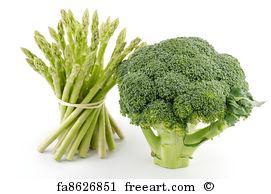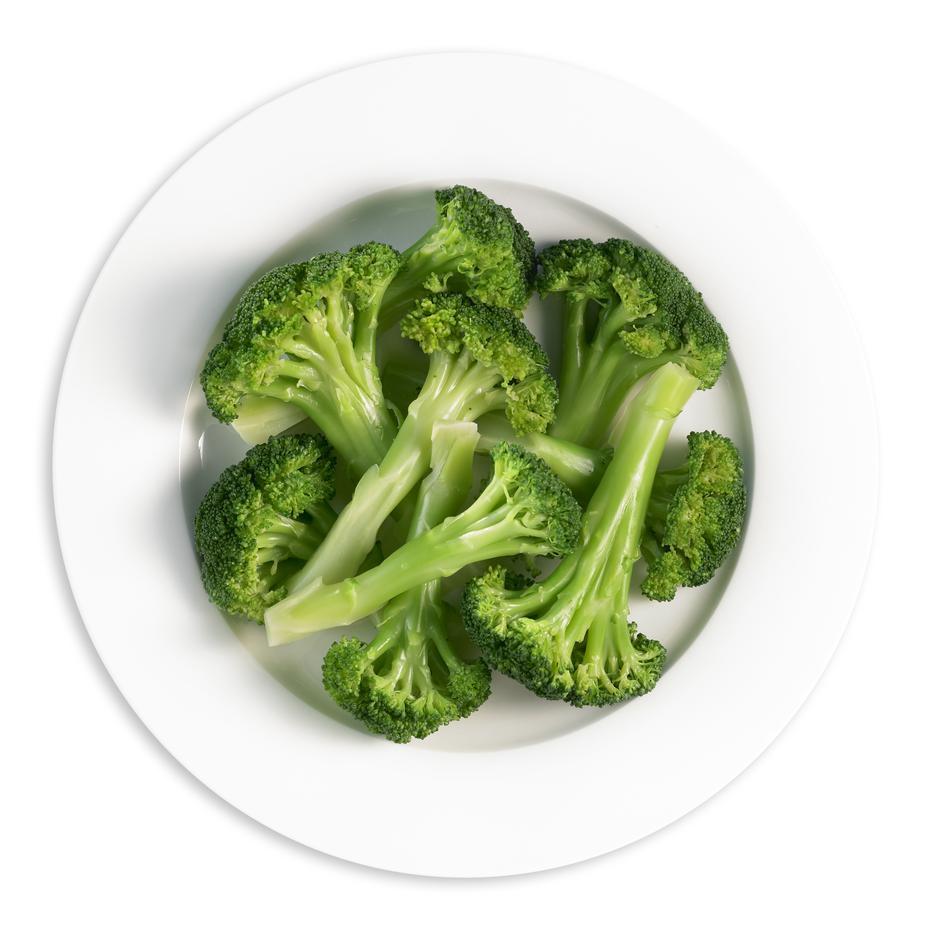The first image is the image on the left, the second image is the image on the right. Analyze the images presented: Is the assertion "There are two veggies shown in the image on the left." valid? Answer yes or no. Yes. The first image is the image on the left, the second image is the image on the right. Considering the images on both sides, is "An image shows a round dish that contains only broccoli." valid? Answer yes or no. Yes. 